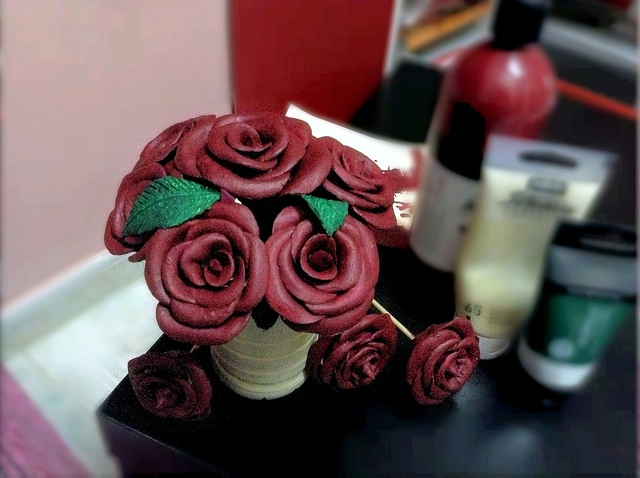Describe the objects in this image and their specific colors. I can see bottle in darkgray, black, gray, maroon, and brown tones and vase in darkgray, gray, black, and darkgreen tones in this image. 